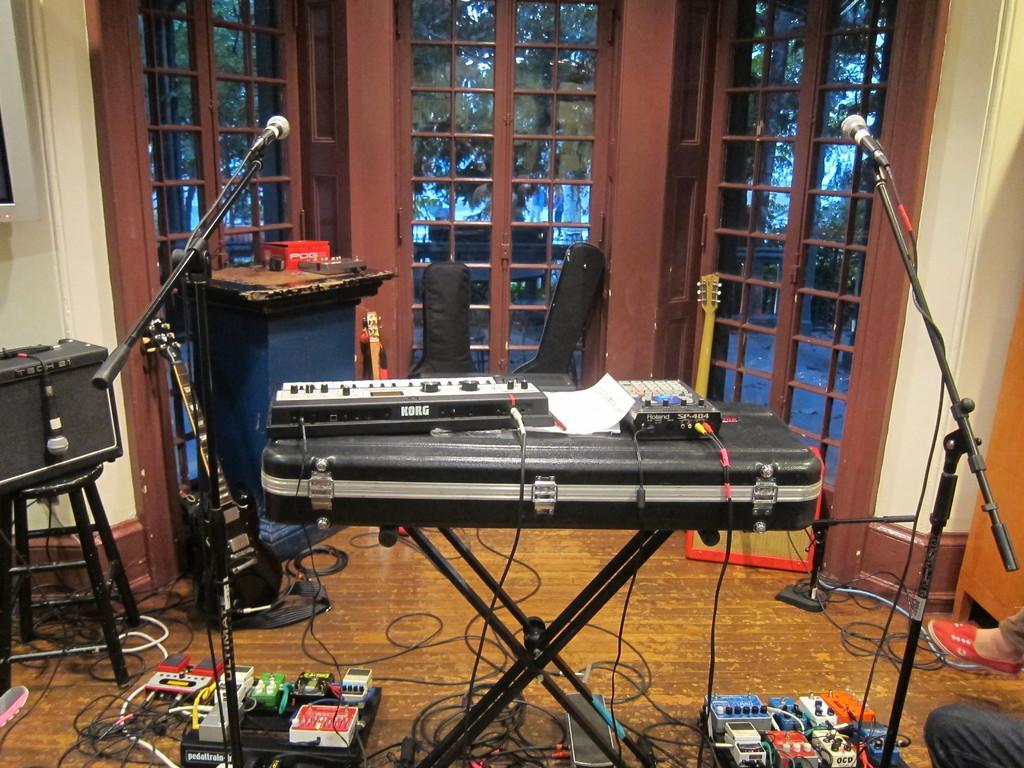In one or two sentences, can you explain what this image depicts? In this image, we can see musical instruments and there are wires and mics with stands and we can see some people and there are windows, through the glass we can see trees and there is a wall. At the bottom, there is a floor. 